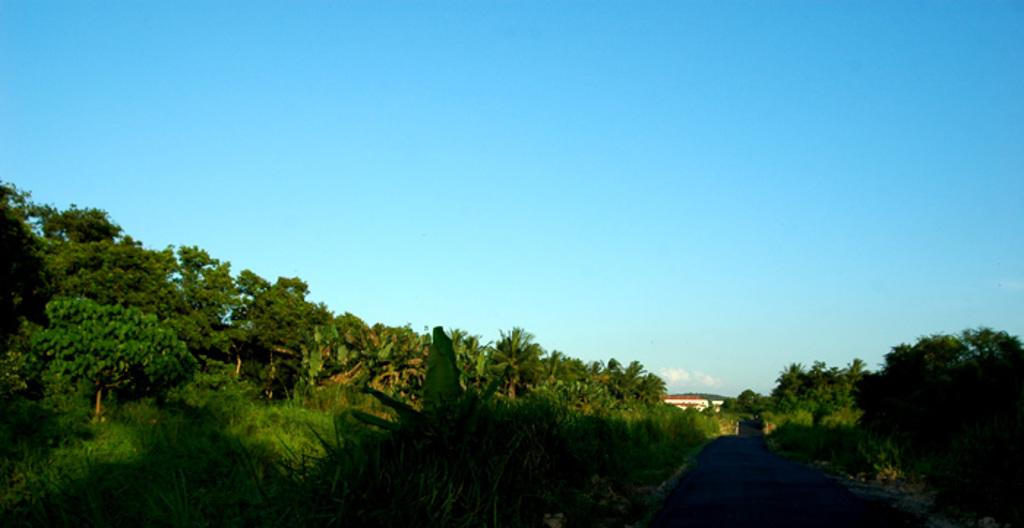What types of vegetation can be seen in the foreground of the picture? There are trees and plants in the foreground of the picture. What else can be seen in the foreground of the picture besides vegetation? There are other objects in the foreground of the picture. What is the main structure in the center of the picture? There is a building in the center of the picture. What is visible at the top of the picture? The sky is visible at the top of the picture. What songs are being sung by the trees in the foreground of the picture? There are no songs being sung by the trees in the picture, as trees do not have the ability to sing. How many cracks can be seen in the building in the center of the picture? There is no mention of cracks in the building in the provided facts, so it cannot be determined from the image. 